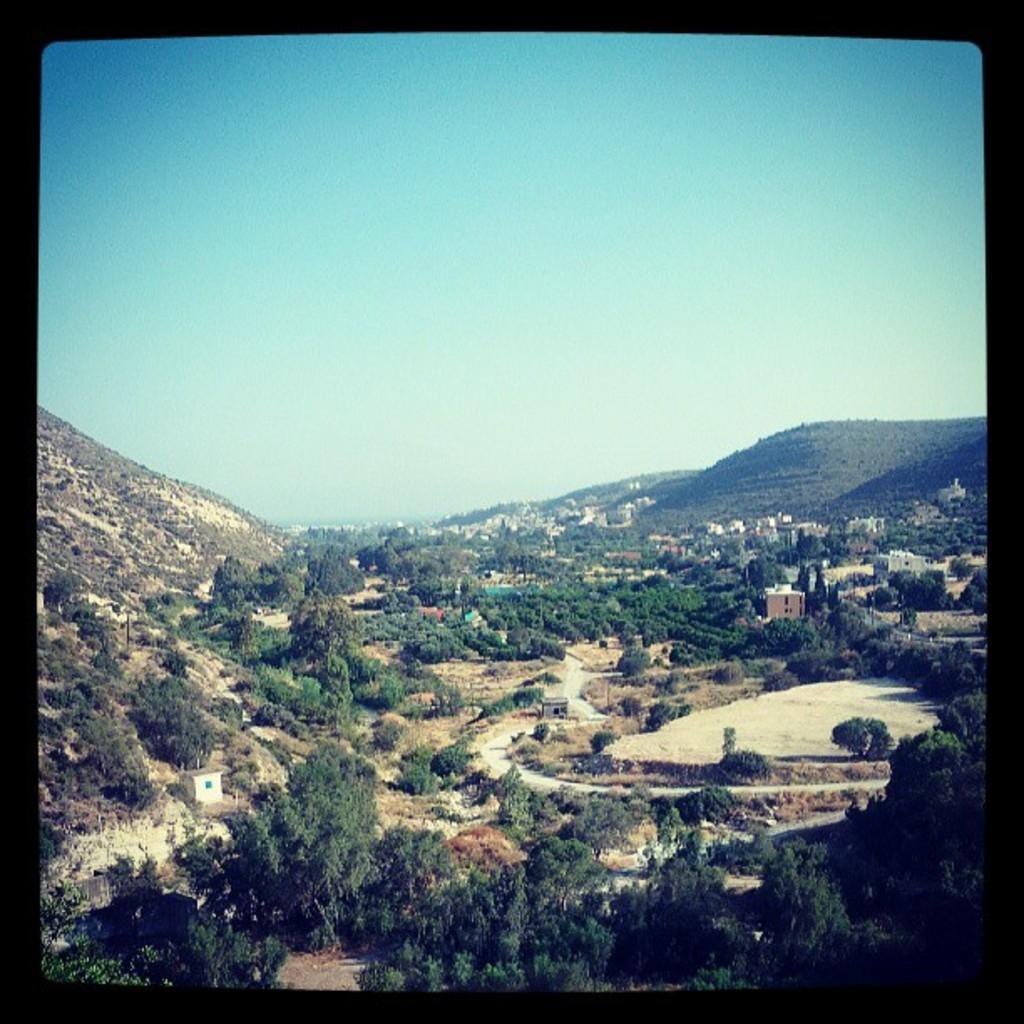Describe this image in one or two sentences. In this image, we can see a photo, in that photo, we can see some trees, there are some buildings, mountains and at the top we can see the sky. 